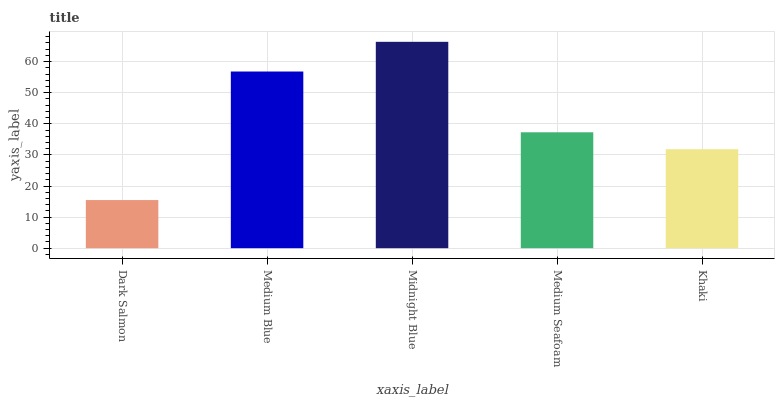Is Medium Blue the minimum?
Answer yes or no. No. Is Medium Blue the maximum?
Answer yes or no. No. Is Medium Blue greater than Dark Salmon?
Answer yes or no. Yes. Is Dark Salmon less than Medium Blue?
Answer yes or no. Yes. Is Dark Salmon greater than Medium Blue?
Answer yes or no. No. Is Medium Blue less than Dark Salmon?
Answer yes or no. No. Is Medium Seafoam the high median?
Answer yes or no. Yes. Is Medium Seafoam the low median?
Answer yes or no. Yes. Is Midnight Blue the high median?
Answer yes or no. No. Is Medium Blue the low median?
Answer yes or no. No. 